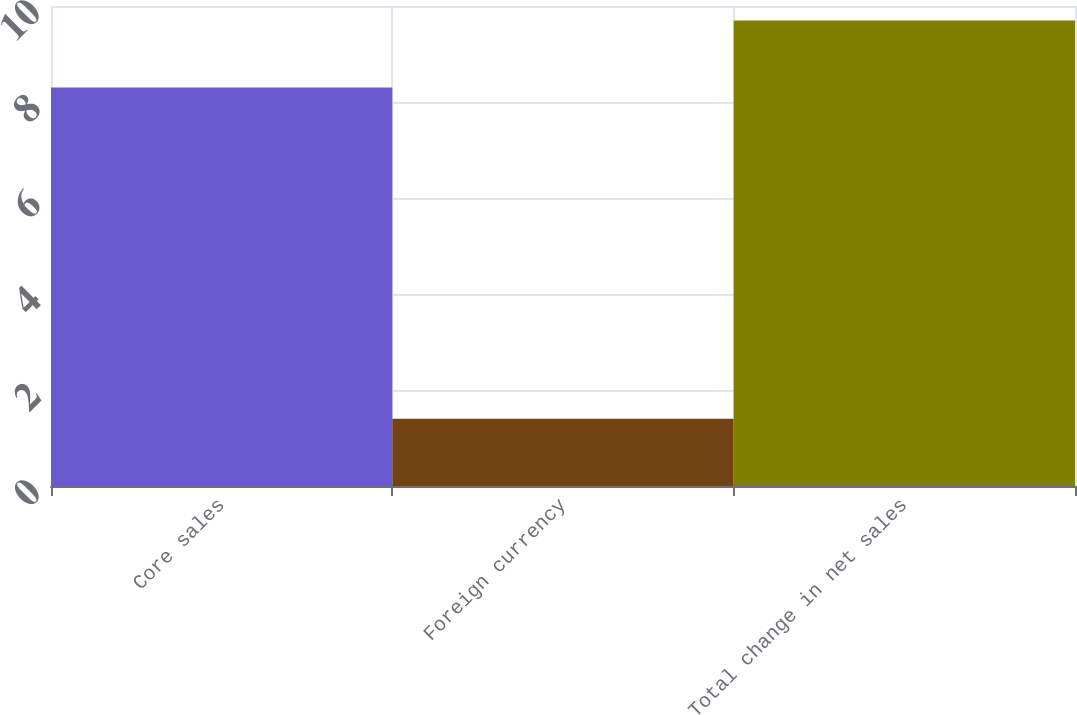Convert chart to OTSL. <chart><loc_0><loc_0><loc_500><loc_500><bar_chart><fcel>Core sales<fcel>Foreign currency<fcel>Total change in net sales<nl><fcel>8.3<fcel>1.4<fcel>9.7<nl></chart> 